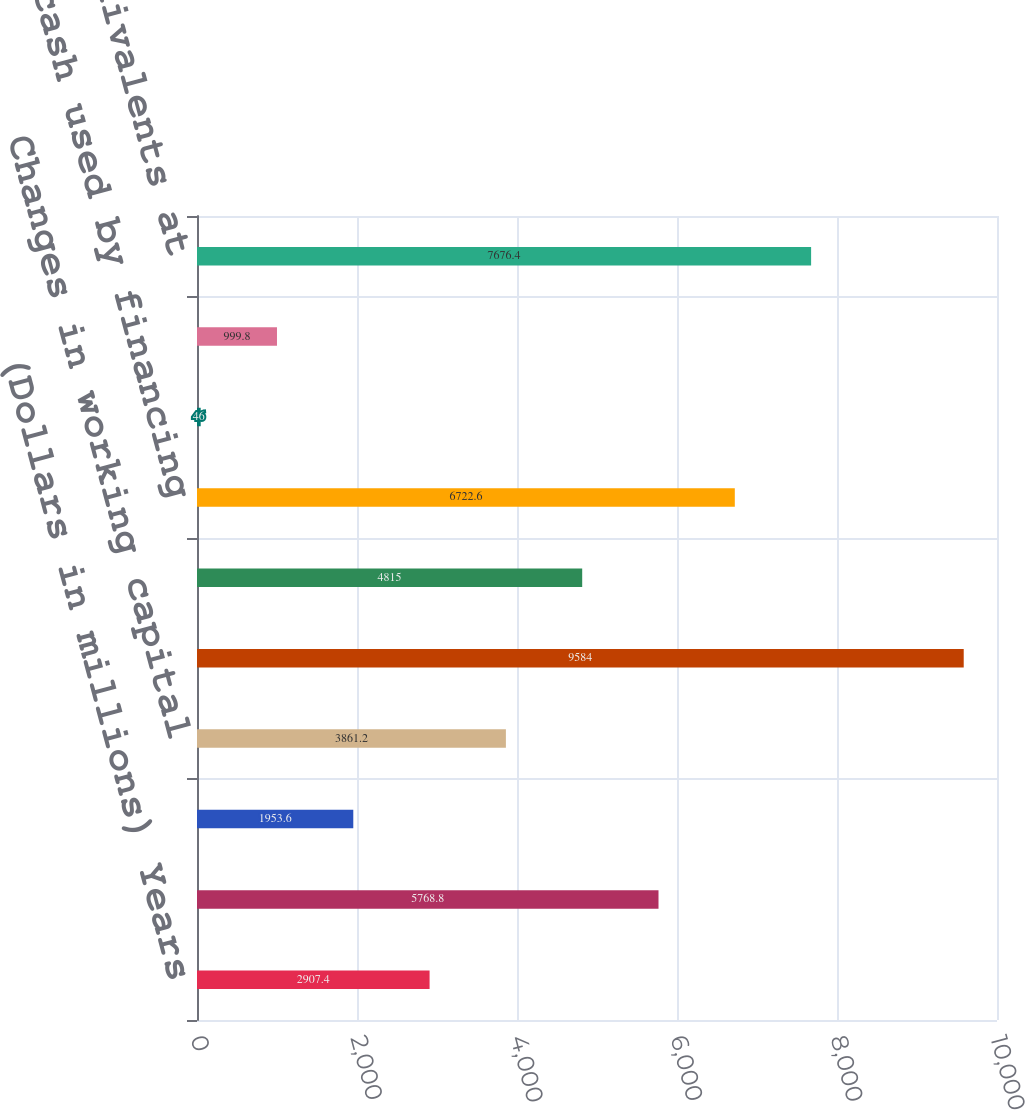<chart> <loc_0><loc_0><loc_500><loc_500><bar_chart><fcel>(Dollars in millions) Years<fcel>Net earnings<fcel>Non-cash items<fcel>Changes in working capital<fcel>Net cash (used)/provided by<fcel>Net cash provided/(used) by<fcel>Net cash used by financing<fcel>Effect of exchange rate<fcel>Net (decrease)/increase in<fcel>Cash and cash equivalents at<nl><fcel>2907.4<fcel>5768.8<fcel>1953.6<fcel>3861.2<fcel>9584<fcel>4815<fcel>6722.6<fcel>46<fcel>999.8<fcel>7676.4<nl></chart> 